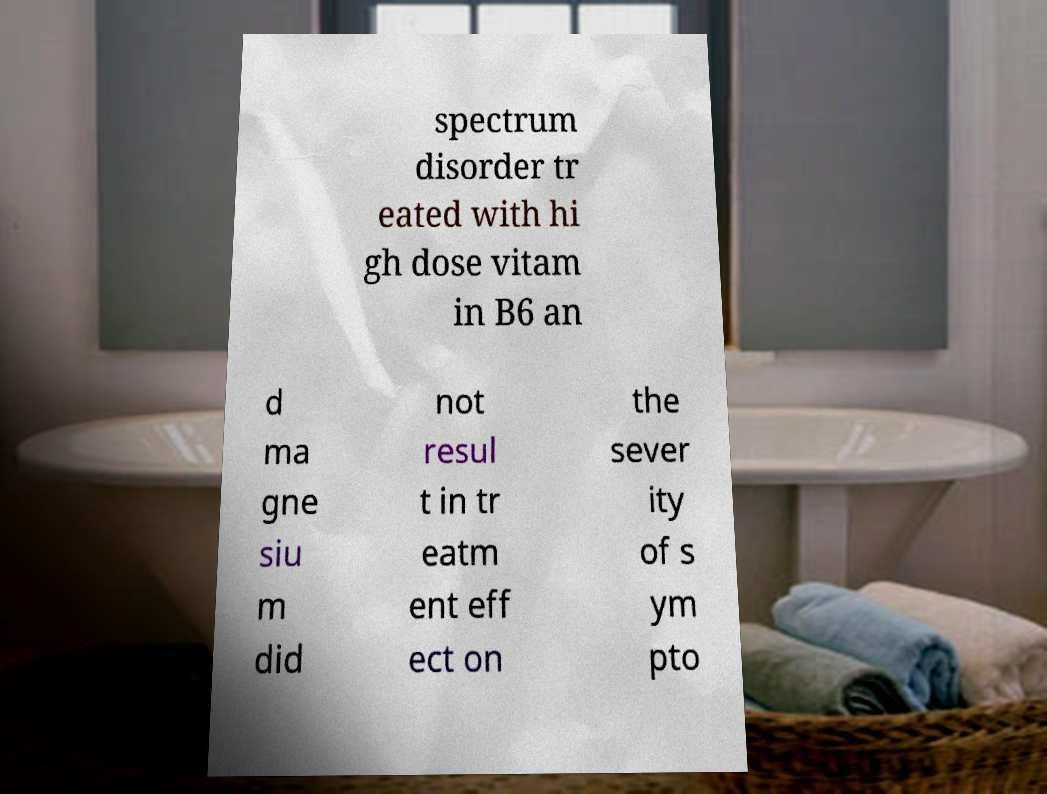Please identify and transcribe the text found in this image. spectrum disorder tr eated with hi gh dose vitam in B6 an d ma gne siu m did not resul t in tr eatm ent eff ect on the sever ity of s ym pto 